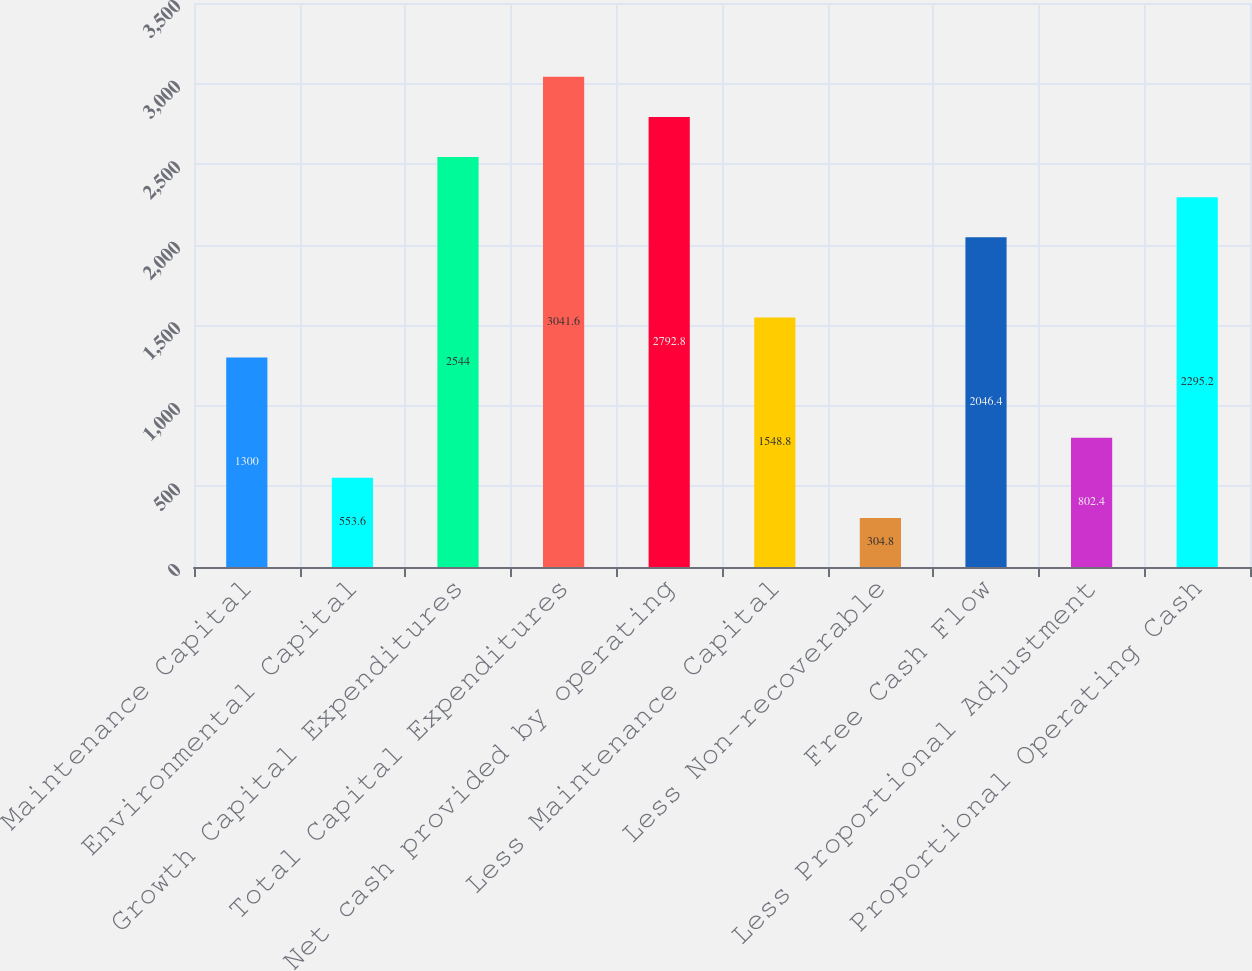Convert chart to OTSL. <chart><loc_0><loc_0><loc_500><loc_500><bar_chart><fcel>Maintenance Capital<fcel>Environmental Capital<fcel>Growth Capital Expenditures<fcel>Total Capital Expenditures<fcel>Net cash provided by operating<fcel>Less Maintenance Capital<fcel>Less Non-recoverable<fcel>Free Cash Flow<fcel>Less Proportional Adjustment<fcel>Proportional Operating Cash<nl><fcel>1300<fcel>553.6<fcel>2544<fcel>3041.6<fcel>2792.8<fcel>1548.8<fcel>304.8<fcel>2046.4<fcel>802.4<fcel>2295.2<nl></chart> 